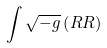Convert formula to latex. <formula><loc_0><loc_0><loc_500><loc_500>\int \sqrt { - g } \left ( R R \right )</formula> 